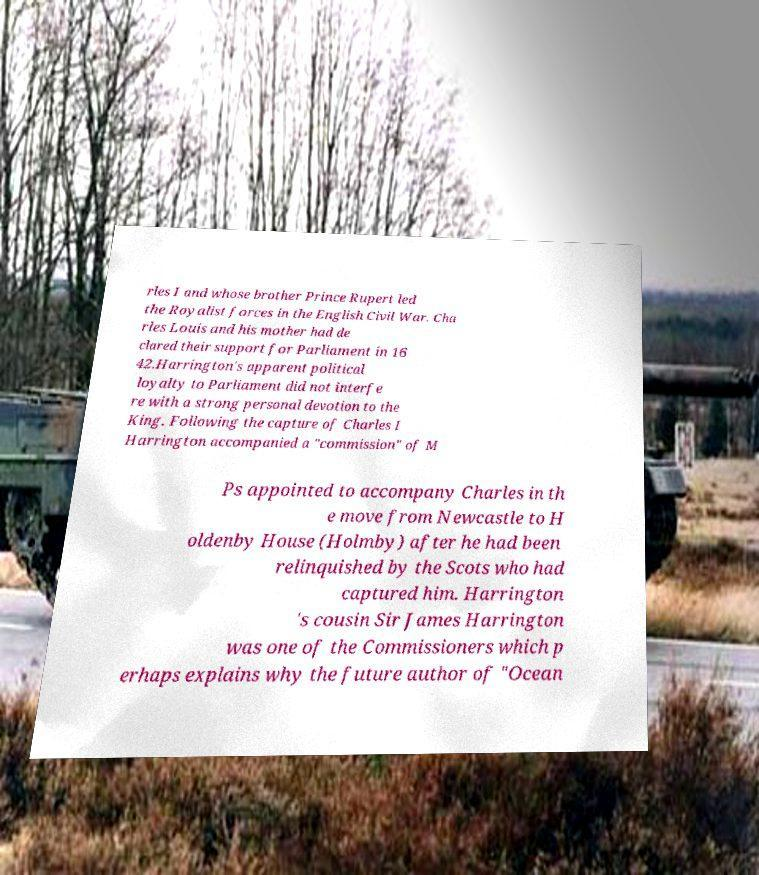Please read and relay the text visible in this image. What does it say? rles I and whose brother Prince Rupert led the Royalist forces in the English Civil War. Cha rles Louis and his mother had de clared their support for Parliament in 16 42.Harrington's apparent political loyalty to Parliament did not interfe re with a strong personal devotion to the King. Following the capture of Charles I Harrington accompanied a "commission" of M Ps appointed to accompany Charles in th e move from Newcastle to H oldenby House (Holmby) after he had been relinquished by the Scots who had captured him. Harrington 's cousin Sir James Harrington was one of the Commissioners which p erhaps explains why the future author of "Ocean 